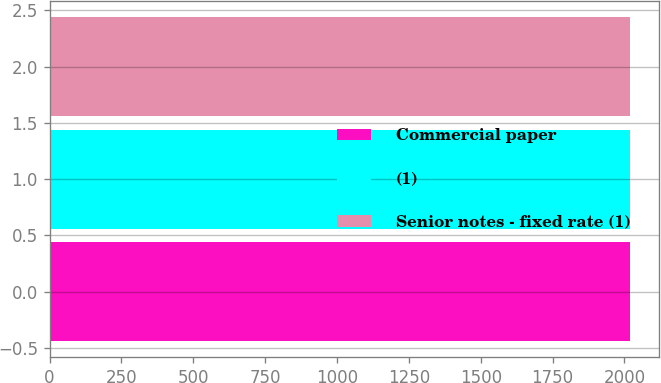<chart> <loc_0><loc_0><loc_500><loc_500><bar_chart><fcel>Commercial paper<fcel>(1)<fcel>Senior notes - fixed rate (1)<nl><fcel>2019<fcel>2018<fcel>2019.1<nl></chart> 